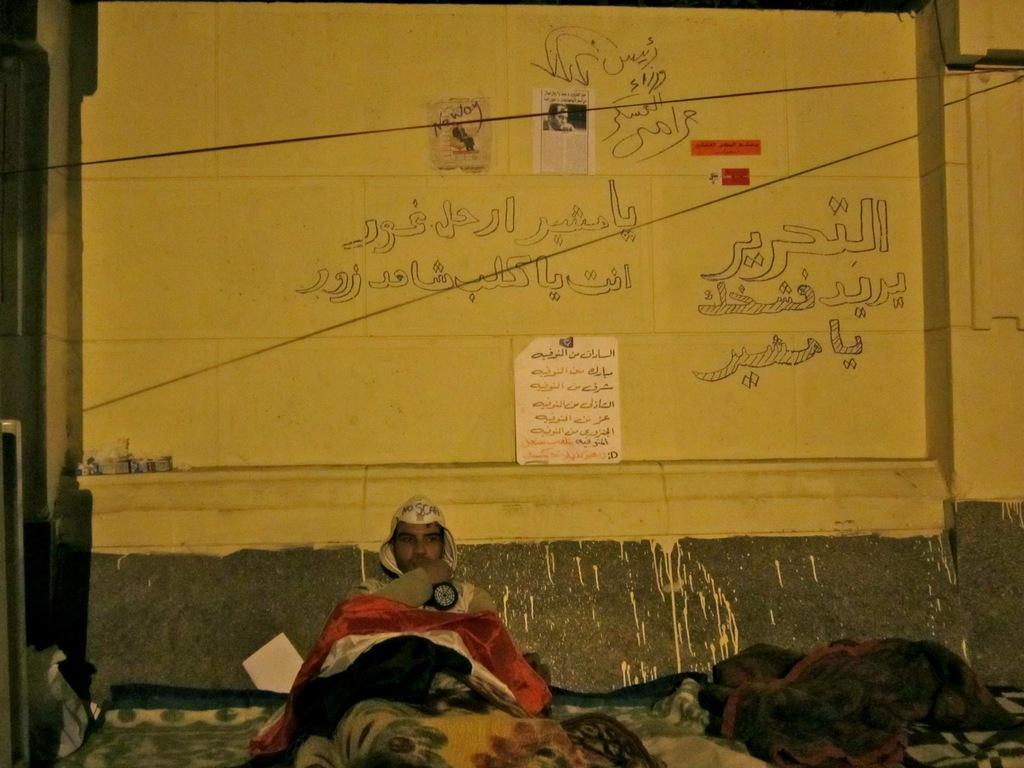What is the man in the image doing? The man is sitting on the bed in the image. What else can be seen in the image besides the man? Clothes are visible in the image. What is in the background of the image? There is a wall in the background of the image. What is on the wall in the background? There are posters on the wall in the background. What type of oil is being used for breakfast in the image? There is no reference to breakfast or oil in the image, so it is not possible to answer that question. 